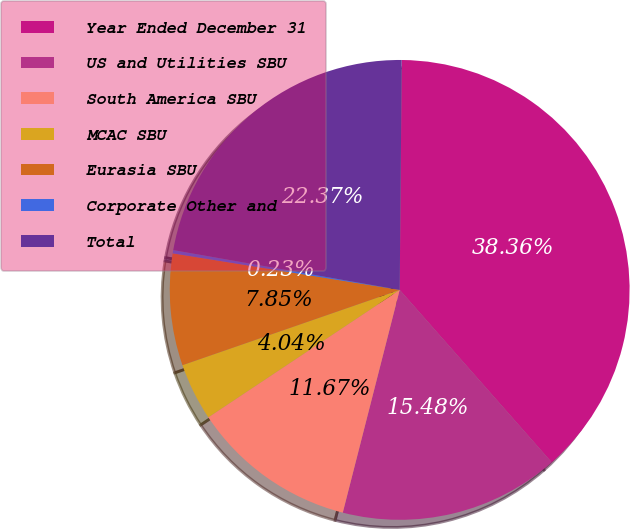<chart> <loc_0><loc_0><loc_500><loc_500><pie_chart><fcel>Year Ended December 31<fcel>US and Utilities SBU<fcel>South America SBU<fcel>MCAC SBU<fcel>Eurasia SBU<fcel>Corporate Other and<fcel>Total<nl><fcel>38.36%<fcel>15.48%<fcel>11.67%<fcel>4.04%<fcel>7.85%<fcel>0.23%<fcel>22.37%<nl></chart> 